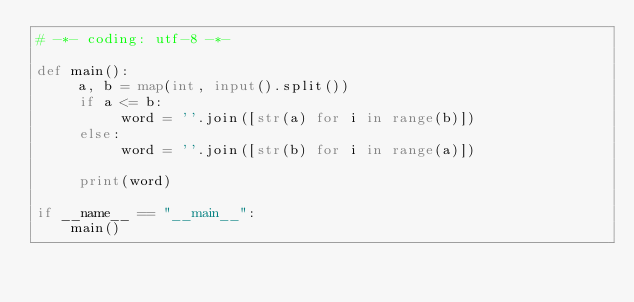Convert code to text. <code><loc_0><loc_0><loc_500><loc_500><_Python_># -*- coding: utf-8 -*-

def main():
     a, b = map(int, input().split())
     if a <= b:
          word = ''.join([str(a) for i in range(b)])
     else:
          word = ''.join([str(b) for i in range(a)])

     print(word)

if __name__ == "__main__":
    main()
</code> 